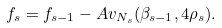<formula> <loc_0><loc_0><loc_500><loc_500>f _ { s } = f _ { s - 1 } - A v _ { N _ { s } } ( \beta _ { s - 1 } , 4 \rho _ { s } ) .</formula> 